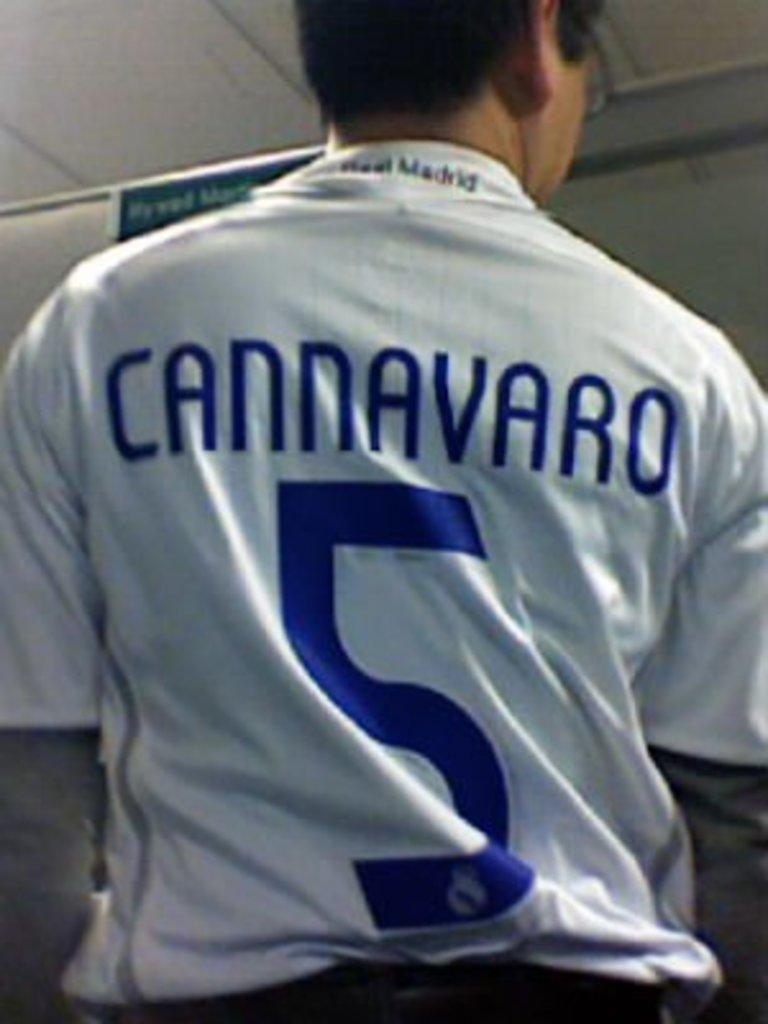<image>
Render a clear and concise summary of the photo. single man with a sport jersey that reads cannavaro 